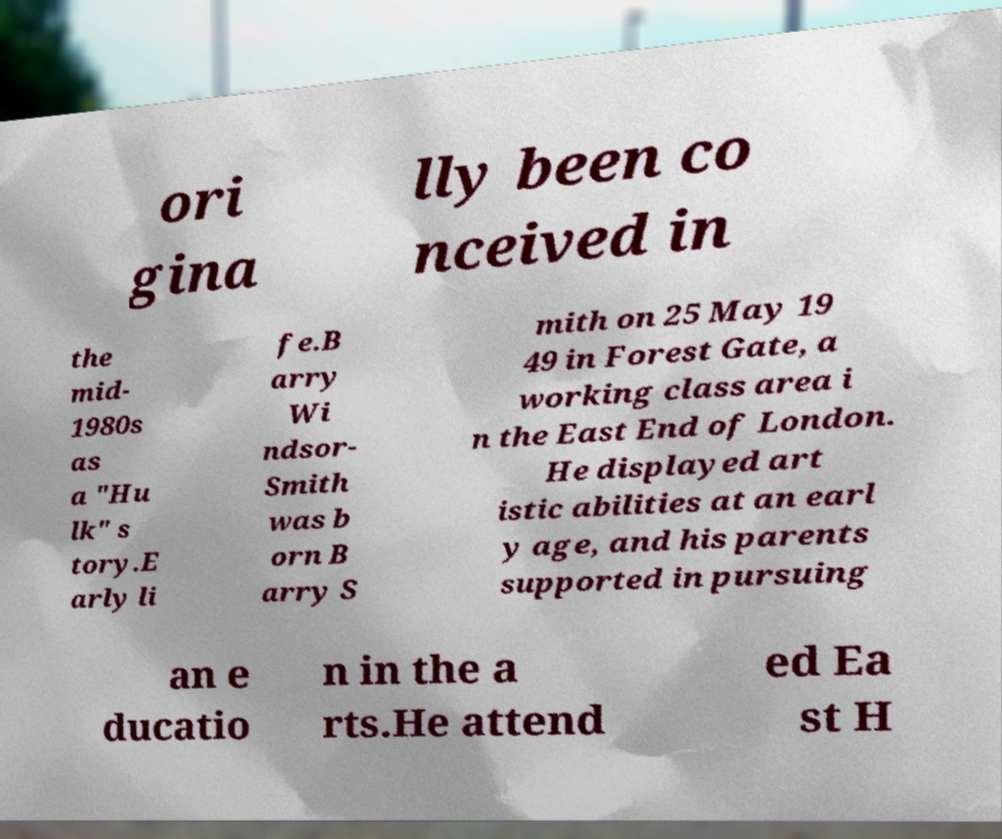I need the written content from this picture converted into text. Can you do that? ori gina lly been co nceived in the mid- 1980s as a "Hu lk" s tory.E arly li fe.B arry Wi ndsor- Smith was b orn B arry S mith on 25 May 19 49 in Forest Gate, a working class area i n the East End of London. He displayed art istic abilities at an earl y age, and his parents supported in pursuing an e ducatio n in the a rts.He attend ed Ea st H 